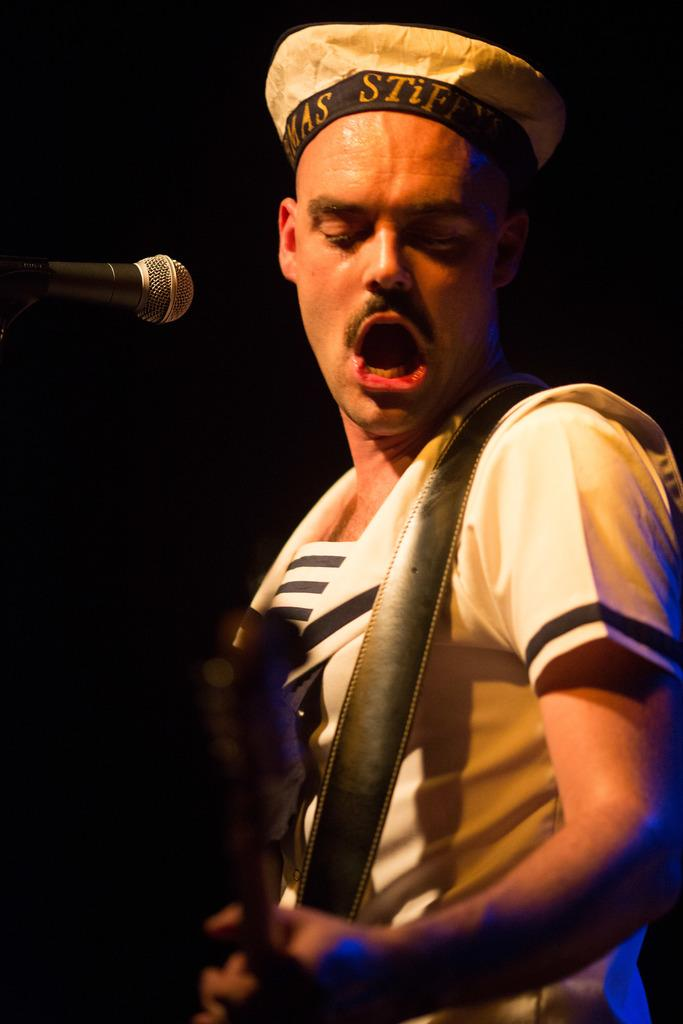Who is the main subject in the image? There is a man in the image. What is the man wearing on his head? The man is wearing a cap. What is the man doing in the image? The man is playing a guitar. What object is in front of the man? There is a microphone in front of the man. Are there any cobwebs visible on the man's cap in the image? There is no mention of cobwebs in the provided facts, and therefore we cannot determine if any are present on the man's cap. How far away is the man from the camera in the image? The provided facts do not give any information about the distance between the man and the camera, so we cannot determine this information. 